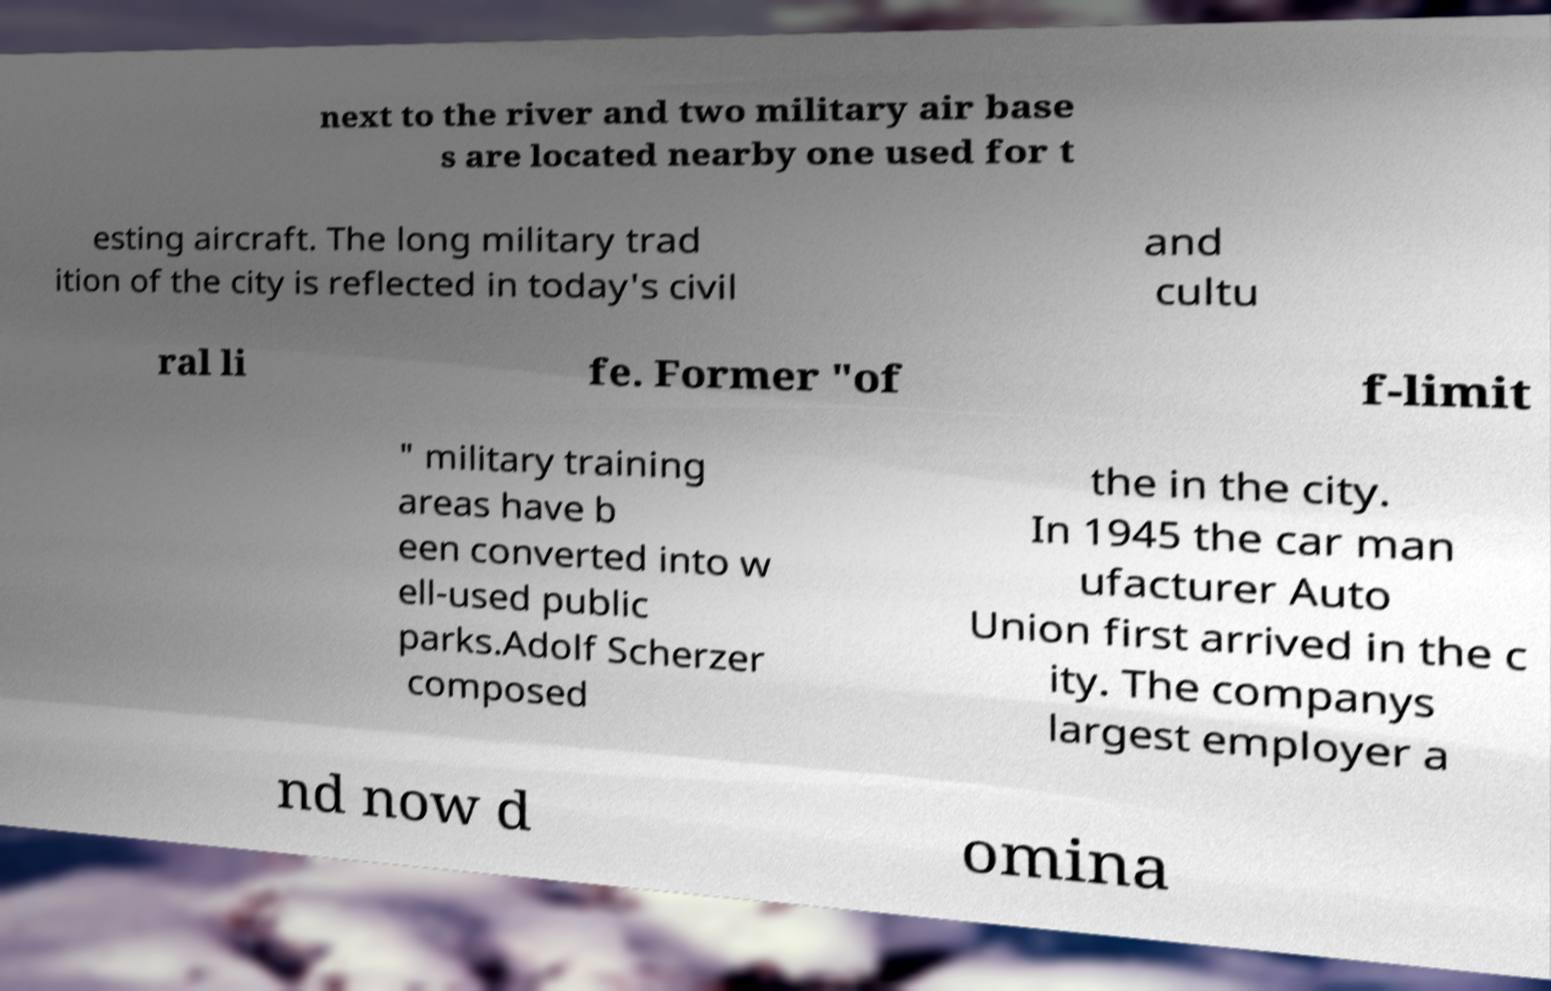Please read and relay the text visible in this image. What does it say? next to the river and two military air base s are located nearby one used for t esting aircraft. The long military trad ition of the city is reflected in today's civil and cultu ral li fe. Former "of f-limit " military training areas have b een converted into w ell-used public parks.Adolf Scherzer composed the in the city. In 1945 the car man ufacturer Auto Union first arrived in the c ity. The companys largest employer a nd now d omina 